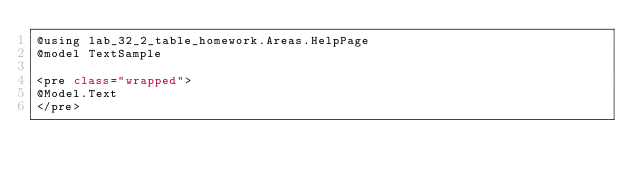Convert code to text. <code><loc_0><loc_0><loc_500><loc_500><_C#_>@using lab_32_2_table_homework.Areas.HelpPage
@model TextSample

<pre class="wrapped">
@Model.Text
</pre></code> 